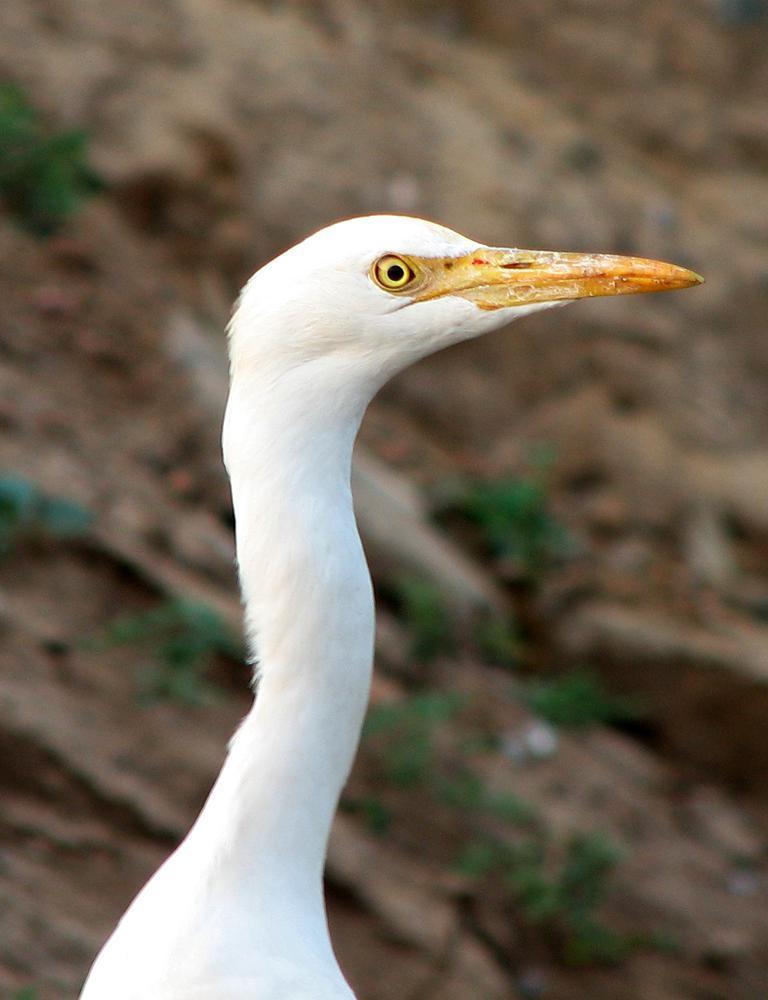Describe this image in one or two sentences. In this image we can see an animal with a long beak. 